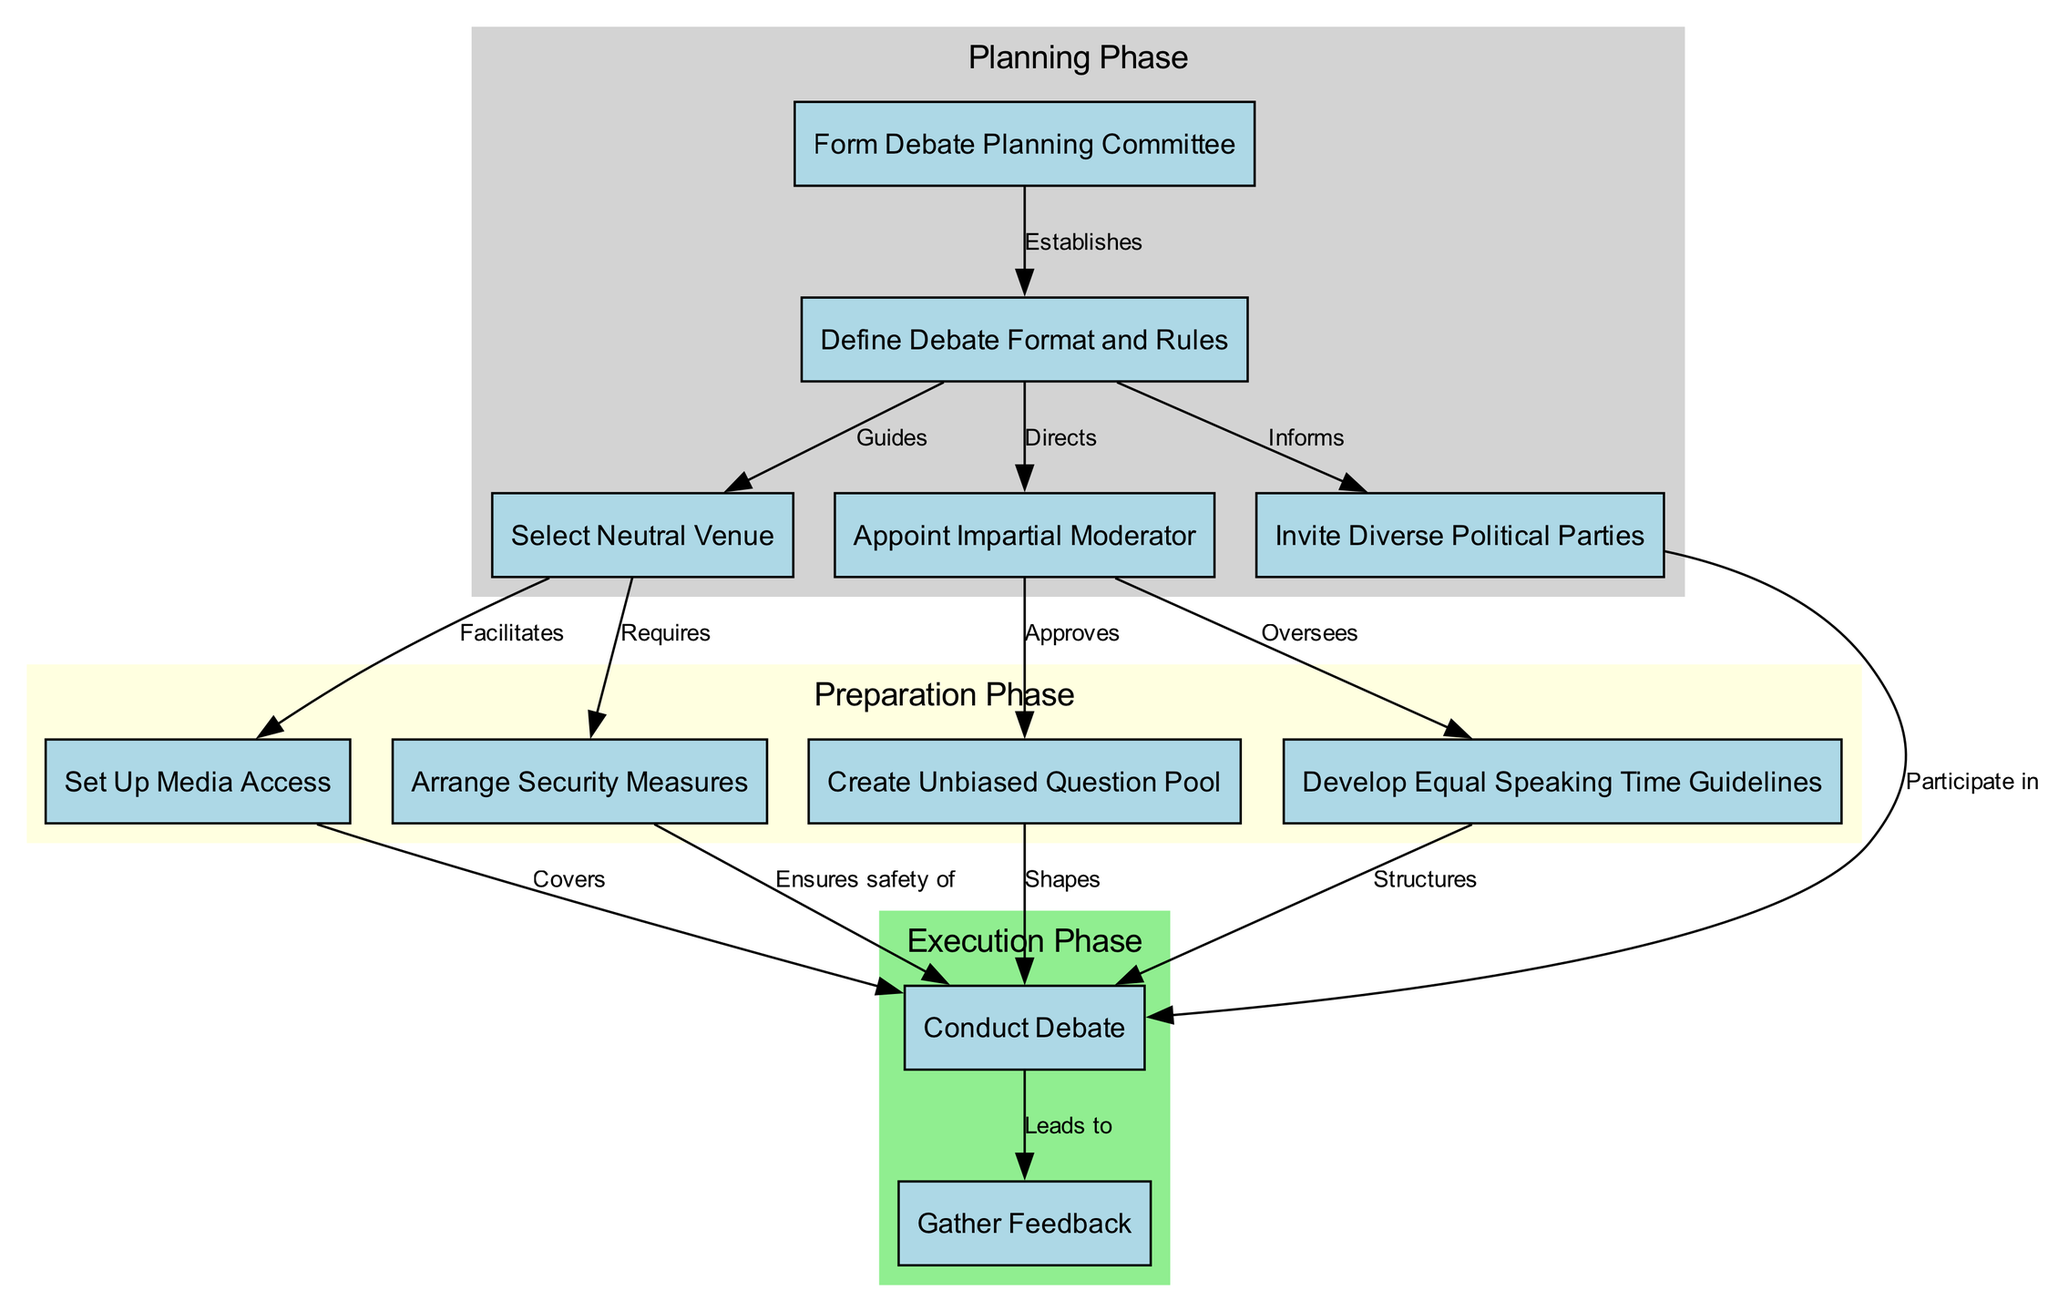What is the first step in the process? The diagram shows that the first step is the "Form Debate Planning Committee," indicated as the top node with the label "Form Debate Planning Committee."
Answer: Form Debate Planning Committee How many nodes are there in total? By counting all the nodes listed in the data, there are 11 nodes including all steps and considerations involved in the process.
Answer: 11 What does the "Define Debate Format and Rules" node guide? The "Define Debate Format and Rules" node guides the selection of the "Select Neutral Venue," "Invite Diverse Political Parties," and "Appoint Impartial Moderator," as indicated by the edges leading to those nodes.
Answer: Select Neutral Venue, Invite Diverse Political Parties, Appoint Impartial Moderator Which node oversees the development of equal speaking time guidelines? According to the diagram, the node "Appoint Impartial Moderator" oversees the "Develop Equal Speaking Time Guidelines," as indicated by the edge connecting them.
Answer: Develop Equal Speaking Time Guidelines What is the final step in the process? The diagram indicates the final step is "Gather Feedback," which is the last node following the "Conduct Debate" node.
Answer: Gather Feedback Which subgraph node includes the "Create Unbiased Question Pool"? The "Create Unbiased Question Pool" is found in the "Preparation Phase" subgraph, which consists of nodes that deal with preparations and guidelines before the debate.
Answer: Preparation Phase What relationship exists between "Conduct Debate" and "Gather Feedback"? The edge connecting "Conduct Debate" to "Gather Feedback" shows a leading relationship, where "Conduct Debate" directly leads to the action of "Gather Feedback."
Answer: Leads to What does the "Arrange Security Measures" node require? The diagram specifies that the "Select Neutral Venue" node requires "Arrange Security Measures," as there is a direct edge showing this requirement.
Answer: Arrange Security Measures 